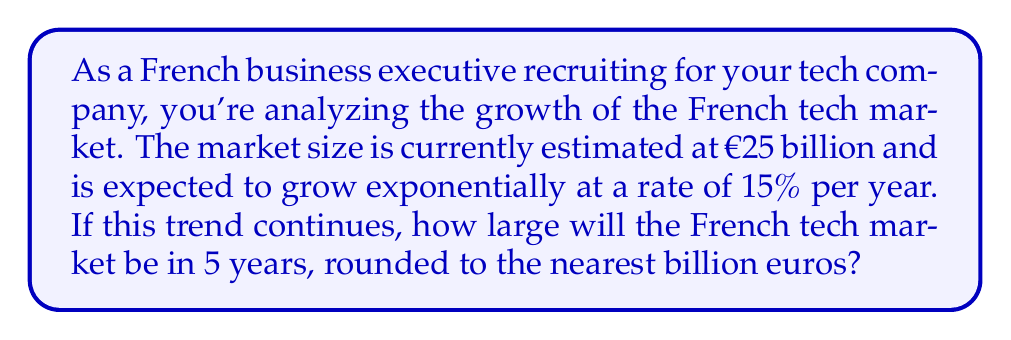Help me with this question. Let's approach this step-by-step:

1) The initial market size is €25 billion, and it's growing at a rate of 15% per year.

2) We can model this using the exponential growth formula:
   $$A = P(1 + r)^t$$
   Where:
   $A$ = Final amount
   $P$ = Initial principal balance
   $r$ = Annual growth rate (in decimal form)
   $t$ = Number of years

3) In this case:
   $P = 25$ billion euros
   $r = 0.15$ (15% expressed as a decimal)
   $t = 5$ years

4) Let's substitute these values into our formula:
   $$A = 25(1 + 0.15)^5$$

5) Now, let's calculate:
   $$A = 25(1.15)^5$$
   $$A = 25(2.0113)$$
   $$A = 50.2825$$ billion euros

6) Rounding to the nearest billion:
   50.2825 ≈ 50 billion euros
Answer: €50 billion 